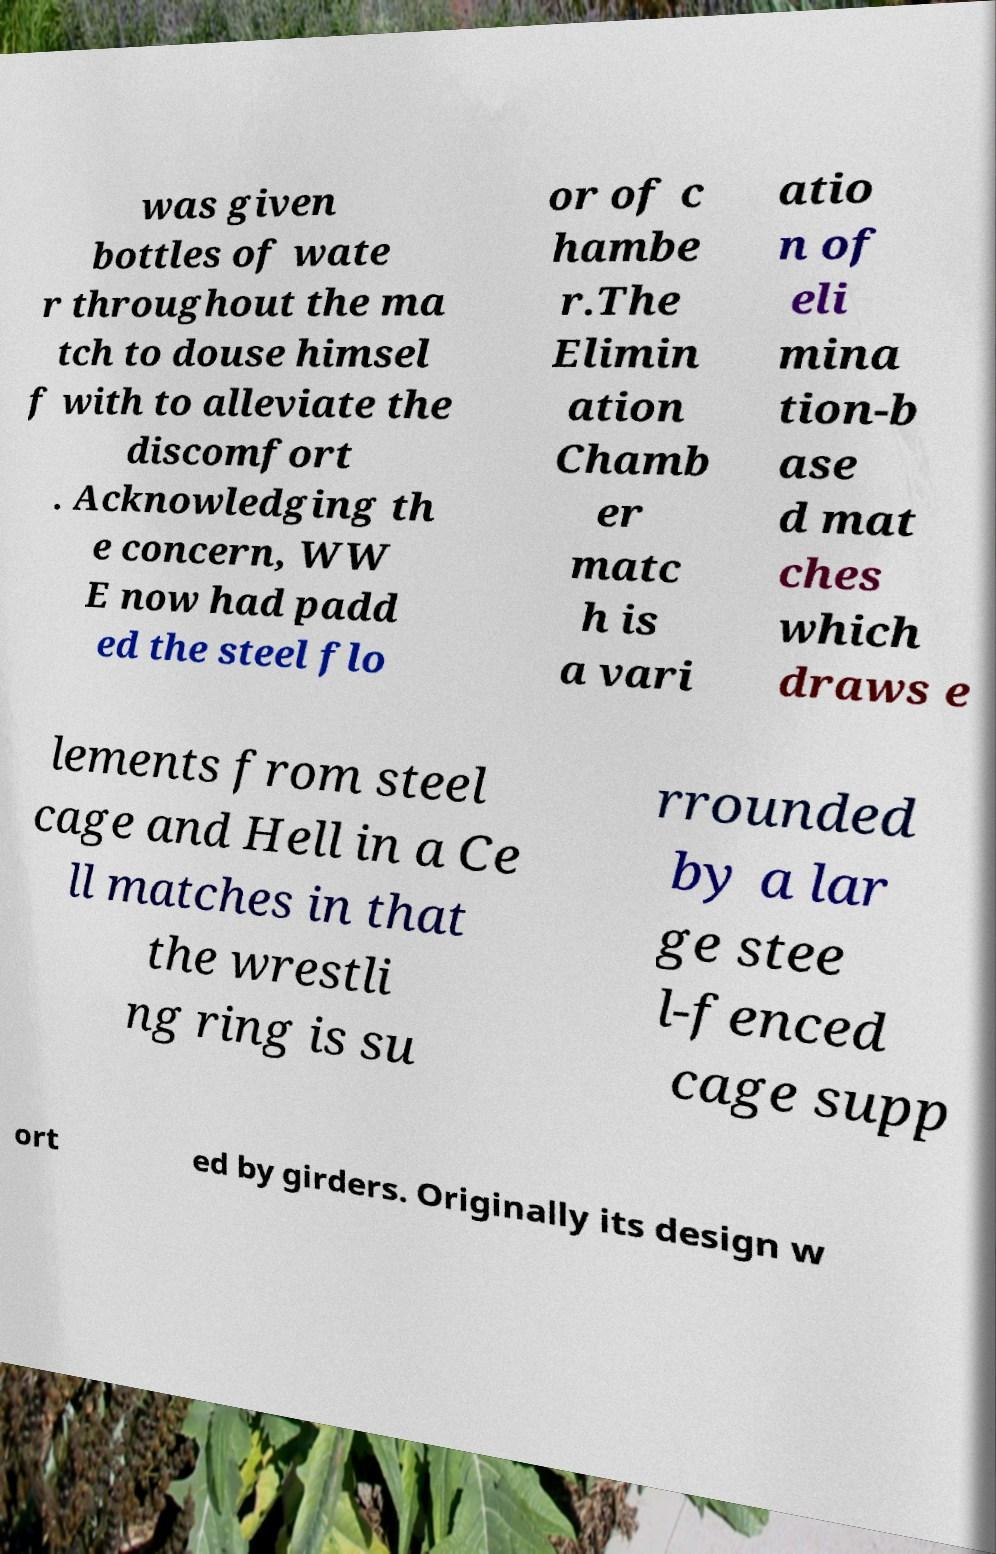Please identify and transcribe the text found in this image. was given bottles of wate r throughout the ma tch to douse himsel f with to alleviate the discomfort . Acknowledging th e concern, WW E now had padd ed the steel flo or of c hambe r.The Elimin ation Chamb er matc h is a vari atio n of eli mina tion-b ase d mat ches which draws e lements from steel cage and Hell in a Ce ll matches in that the wrestli ng ring is su rrounded by a lar ge stee l-fenced cage supp ort ed by girders. Originally its design w 